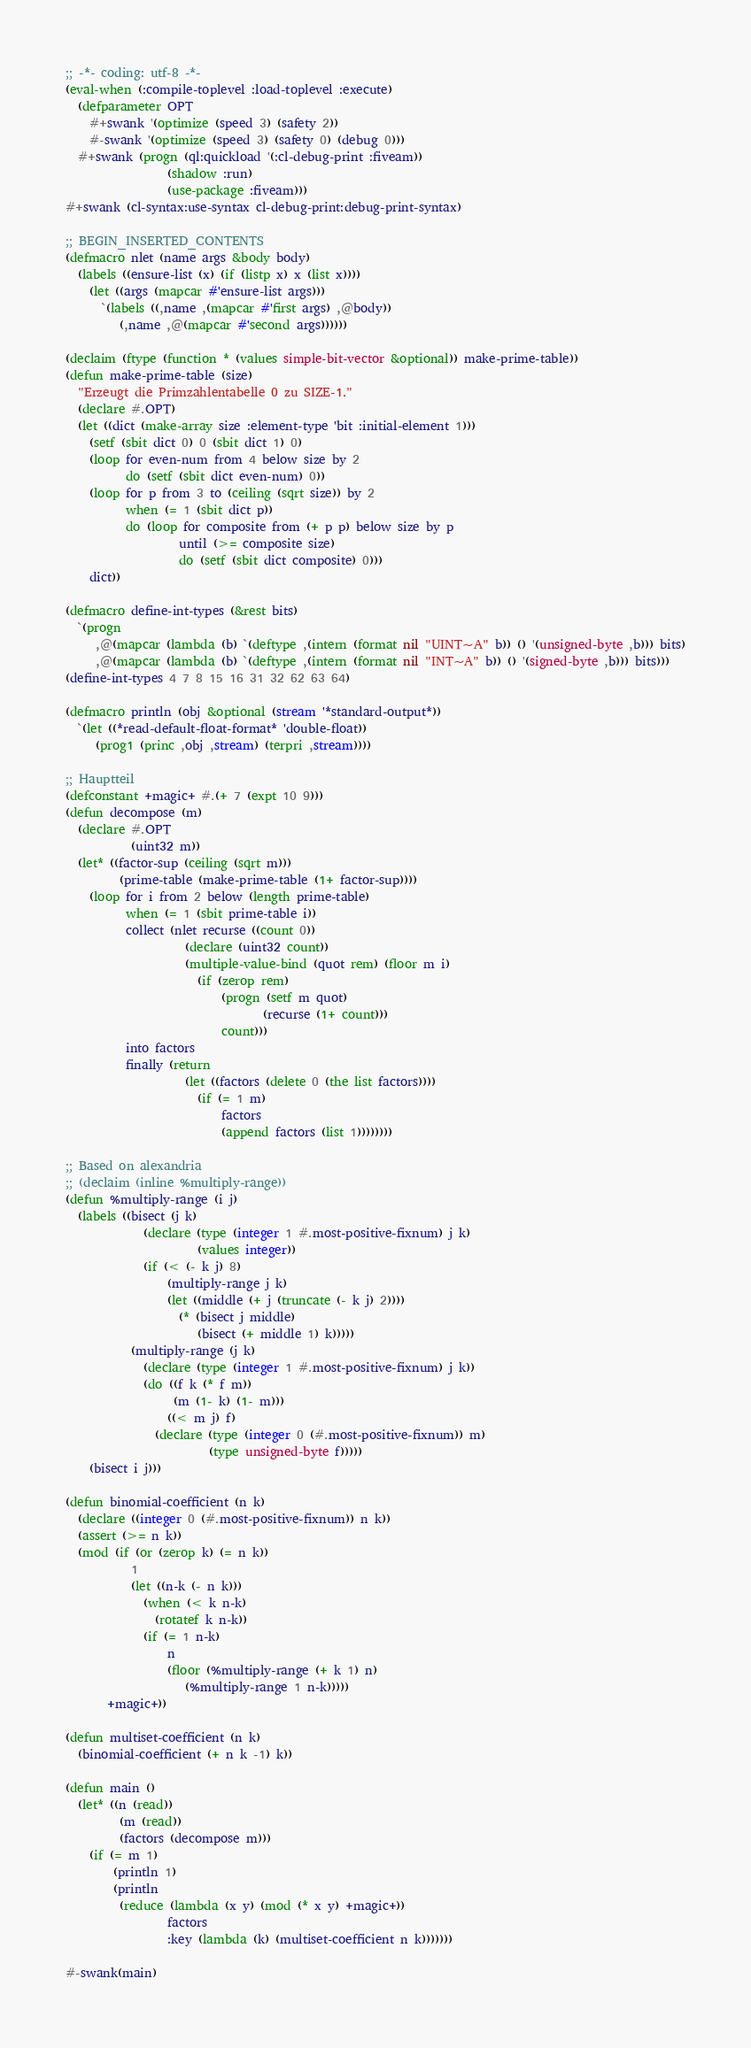<code> <loc_0><loc_0><loc_500><loc_500><_Lisp_>;; -*- coding: utf-8 -*-
(eval-when (:compile-toplevel :load-toplevel :execute)
  (defparameter OPT
    #+swank '(optimize (speed 3) (safety 2))
    #-swank '(optimize (speed 3) (safety 0) (debug 0)))
  #+swank (progn (ql:quickload '(:cl-debug-print :fiveam))
                 (shadow :run)
                 (use-package :fiveam)))
#+swank (cl-syntax:use-syntax cl-debug-print:debug-print-syntax)

;; BEGIN_INSERTED_CONTENTS
(defmacro nlet (name args &body body)
  (labels ((ensure-list (x) (if (listp x) x (list x))))
    (let ((args (mapcar #'ensure-list args)))
      `(labels ((,name ,(mapcar #'first args) ,@body))
         (,name ,@(mapcar #'second args))))))

(declaim (ftype (function * (values simple-bit-vector &optional)) make-prime-table))
(defun make-prime-table (size)
  "Erzeugt die Primzahlentabelle 0 zu SIZE-1."
  (declare #.OPT)
  (let ((dict (make-array size :element-type 'bit :initial-element 1)))
    (setf (sbit dict 0) 0 (sbit dict 1) 0)
    (loop for even-num from 4 below size by 2
          do (setf (sbit dict even-num) 0))
    (loop for p from 3 to (ceiling (sqrt size)) by 2
          when (= 1 (sbit dict p))
          do (loop for composite from (+ p p) below size by p
                   until (>= composite size)
                   do (setf (sbit dict composite) 0)))
    dict))

(defmacro define-int-types (&rest bits)
  `(progn
     ,@(mapcar (lambda (b) `(deftype ,(intern (format nil "UINT~A" b)) () '(unsigned-byte ,b))) bits)
     ,@(mapcar (lambda (b) `(deftype ,(intern (format nil "INT~A" b)) () '(signed-byte ,b))) bits)))
(define-int-types 4 7 8 15 16 31 32 62 63 64)

(defmacro println (obj &optional (stream '*standard-output*))
  `(let ((*read-default-float-format* 'double-float))
     (prog1 (princ ,obj ,stream) (terpri ,stream))))

;; Hauptteil
(defconstant +magic+ #.(+ 7 (expt 10 9)))
(defun decompose (m)
  (declare #.OPT
           (uint32 m))
  (let* ((factor-sup (ceiling (sqrt m)))
         (prime-table (make-prime-table (1+ factor-sup))))
    (loop for i from 2 below (length prime-table)
          when (= 1 (sbit prime-table i))
          collect (nlet recurse ((count 0))
                    (declare (uint32 count))
                    (multiple-value-bind (quot rem) (floor m i)
                      (if (zerop rem)
                          (progn (setf m quot)
                                 (recurse (1+ count)))
                          count)))
          into factors
          finally (return
                    (let ((factors (delete 0 (the list factors))))
                      (if (= 1 m)
                          factors
                          (append factors (list 1))))))))

;; Based on alexandria
;; (declaim (inline %multiply-range))
(defun %multiply-range (i j)
  (labels ((bisect (j k)
             (declare (type (integer 1 #.most-positive-fixnum) j k)
                      (values integer))
             (if (< (- k j) 8)
                 (multiply-range j k)
                 (let ((middle (+ j (truncate (- k j) 2))))
                   (* (bisect j middle)
                      (bisect (+ middle 1) k)))))
           (multiply-range (j k)
             (declare (type (integer 1 #.most-positive-fixnum) j k))
             (do ((f k (* f m))
                  (m (1- k) (1- m)))
                 ((< m j) f)
               (declare (type (integer 0 (#.most-positive-fixnum)) m)
                        (type unsigned-byte f)))))
    (bisect i j)))

(defun binomial-coefficient (n k)
  (declare ((integer 0 (#.most-positive-fixnum)) n k))
  (assert (>= n k))
  (mod (if (or (zerop k) (= n k))
           1
           (let ((n-k (- n k)))
             (when (< k n-k)
               (rotatef k n-k))
             (if (= 1 n-k)
                 n
                 (floor (%multiply-range (+ k 1) n)
	                (%multiply-range 1 n-k)))))
       +magic+))

(defun multiset-coefficient (n k)
  (binomial-coefficient (+ n k -1) k))

(defun main ()
  (let* ((n (read))
         (m (read))
         (factors (decompose m)))
    (if (= m 1)
        (println 1)
        (println
         (reduce (lambda (x y) (mod (* x y) +magic+))
                 factors
                 :key (lambda (k) (multiset-coefficient n k)))))))

#-swank(main)
</code> 